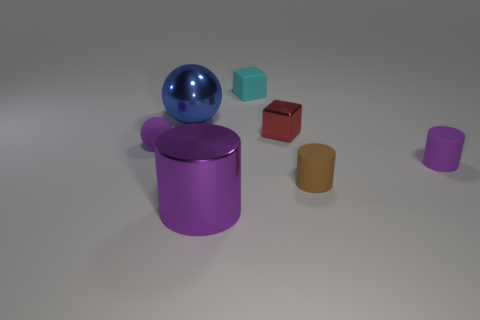Subtract all balls. How many objects are left? 5 Add 1 metal spheres. How many objects exist? 8 Add 2 tiny objects. How many tiny objects are left? 7 Add 7 red matte spheres. How many red matte spheres exist? 7 Subtract 0 red balls. How many objects are left? 7 Subtract all blue balls. Subtract all big balls. How many objects are left? 5 